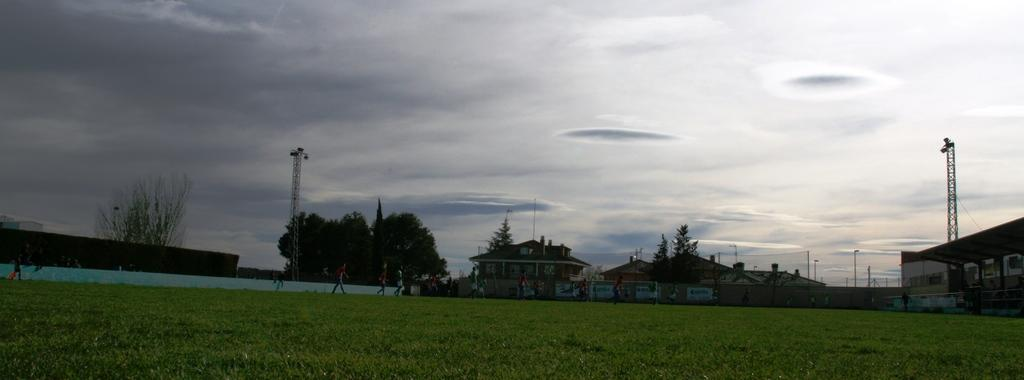What type of vegetation is present in the image? There is grass in the image. What can be seen in the background of the image? There are many people, trees, buildings, poles, and towers in the background of the image. What part of the natural environment is visible in the image? The sky is visible in the background of the image. How many girls are holding nails in the image? There are no girls or nails present in the image. 